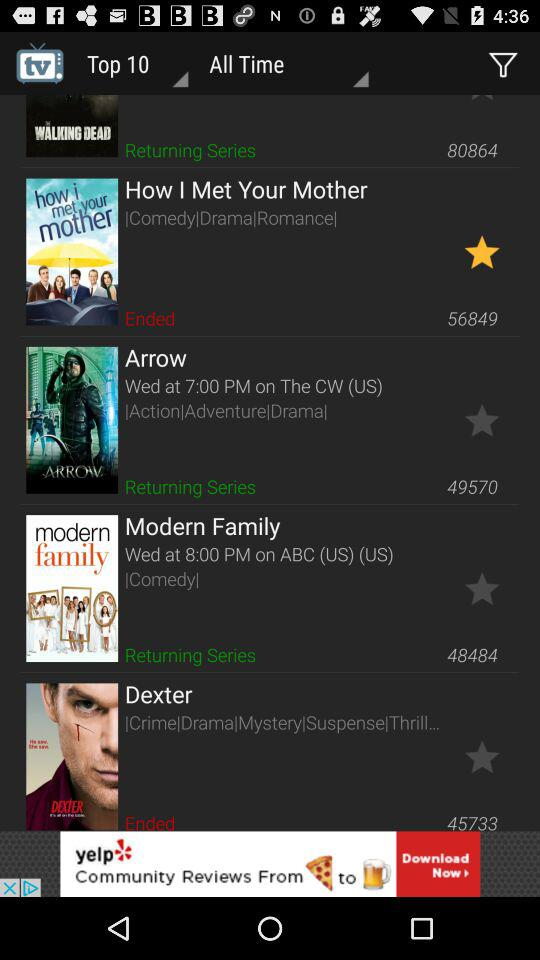What type of series is "Modern Family"? The type of series is comedy. 